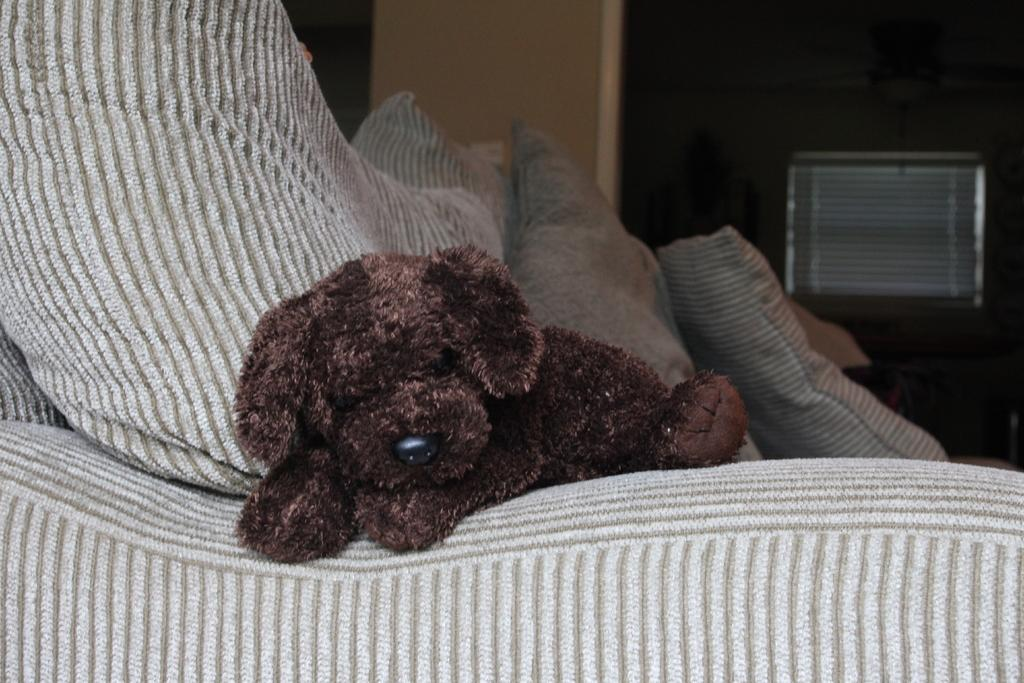What is placed on the sofa in the image? There is a toy on the sofa. What else can be seen on the sofa? There are cushions on the sofa. What is visible in the background of the image? There is a wall in the background of the image. What type of ground can be seen through the window in the image? There is no window or ground visible in the image; it only features a toy, cushions, and a wall in the background. 